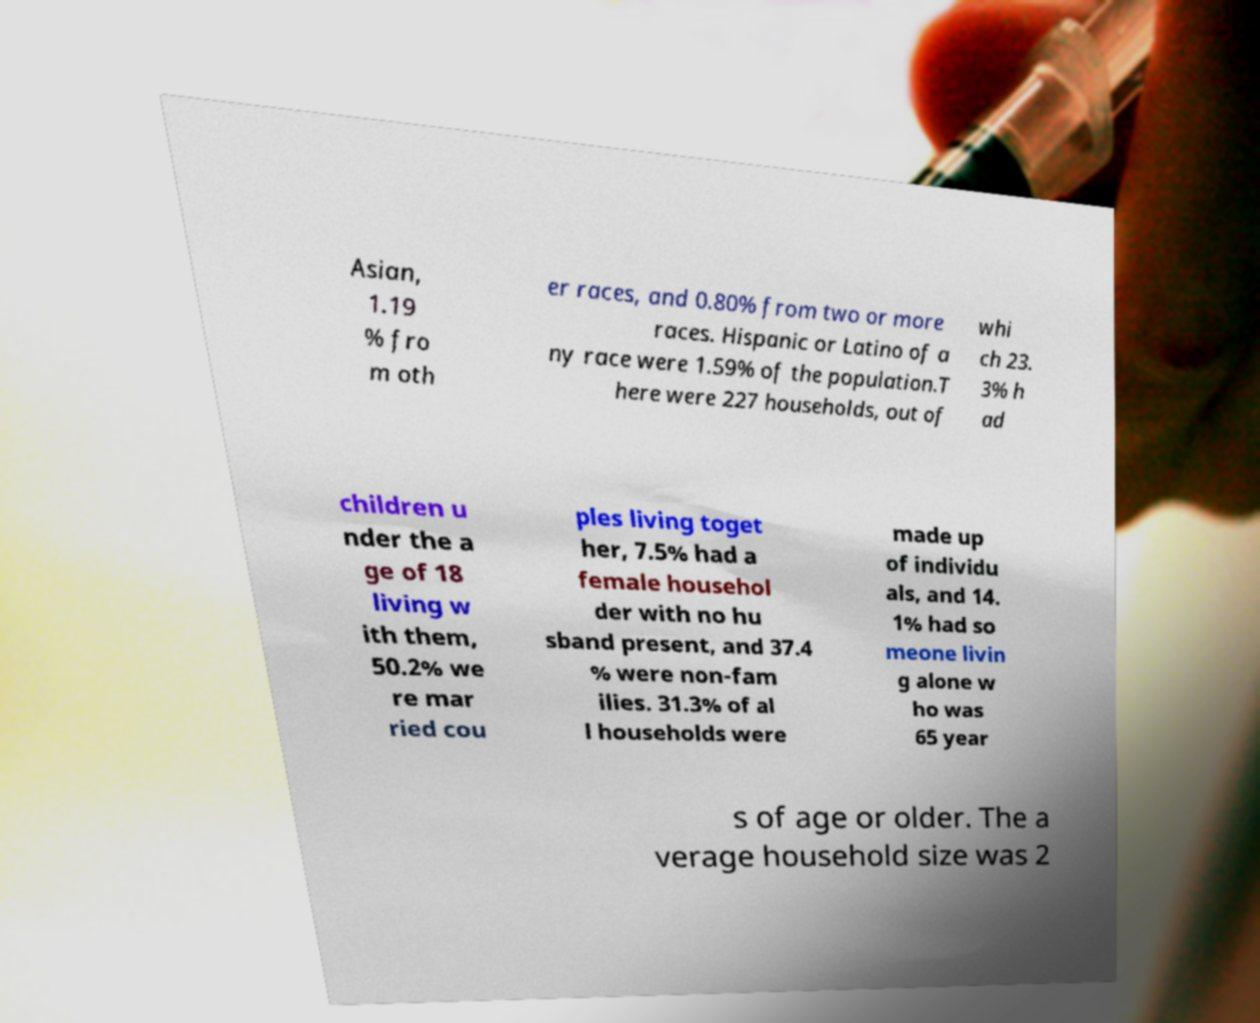Could you assist in decoding the text presented in this image and type it out clearly? Asian, 1.19 % fro m oth er races, and 0.80% from two or more races. Hispanic or Latino of a ny race were 1.59% of the population.T here were 227 households, out of whi ch 23. 3% h ad children u nder the a ge of 18 living w ith them, 50.2% we re mar ried cou ples living toget her, 7.5% had a female househol der with no hu sband present, and 37.4 % were non-fam ilies. 31.3% of al l households were made up of individu als, and 14. 1% had so meone livin g alone w ho was 65 year s of age or older. The a verage household size was 2 